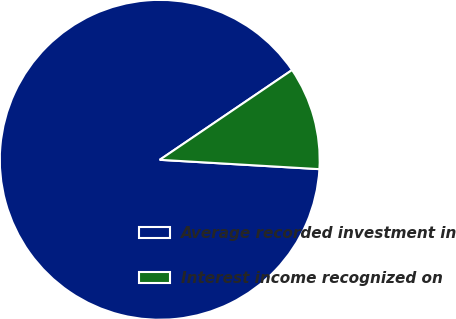Convert chart to OTSL. <chart><loc_0><loc_0><loc_500><loc_500><pie_chart><fcel>Average recorded investment in<fcel>Interest income recognized on<nl><fcel>89.58%<fcel>10.42%<nl></chart> 